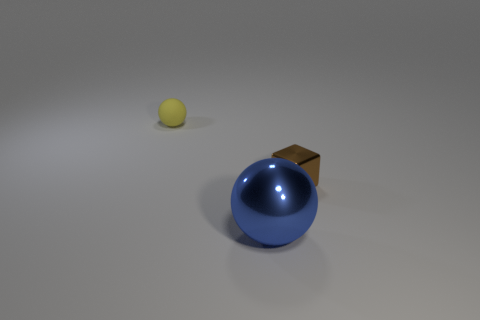Add 1 brown shiny cubes. How many objects exist? 4 Subtract all blue spheres. How many spheres are left? 1 Subtract 2 spheres. How many spheres are left? 0 Subtract all cubes. How many objects are left? 2 Add 3 tiny shiny objects. How many tiny shiny objects exist? 4 Subtract 0 purple cylinders. How many objects are left? 3 Subtract all green cubes. Subtract all cyan cylinders. How many cubes are left? 1 Subtract all red matte things. Subtract all cubes. How many objects are left? 2 Add 1 big metallic spheres. How many big metallic spheres are left? 2 